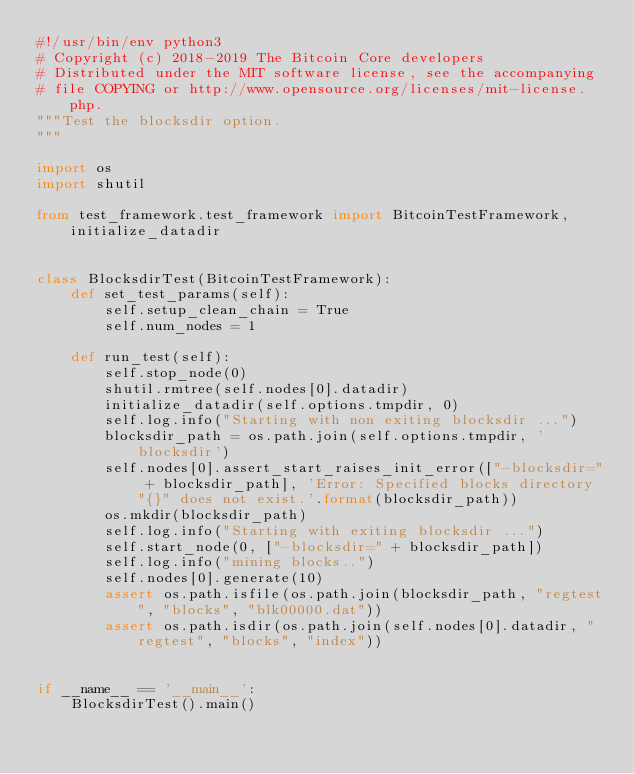<code> <loc_0><loc_0><loc_500><loc_500><_Python_>#!/usr/bin/env python3
# Copyright (c) 2018-2019 The Bitcoin Core developers
# Distributed under the MIT software license, see the accompanying
# file COPYING or http://www.opensource.org/licenses/mit-license.php.
"""Test the blocksdir option.
"""

import os
import shutil

from test_framework.test_framework import BitcoinTestFramework, initialize_datadir


class BlocksdirTest(BitcoinTestFramework):
    def set_test_params(self):
        self.setup_clean_chain = True
        self.num_nodes = 1

    def run_test(self):
        self.stop_node(0)
        shutil.rmtree(self.nodes[0].datadir)
        initialize_datadir(self.options.tmpdir, 0)
        self.log.info("Starting with non exiting blocksdir ...")
        blocksdir_path = os.path.join(self.options.tmpdir, 'blocksdir')
        self.nodes[0].assert_start_raises_init_error(["-blocksdir=" + blocksdir_path], 'Error: Specified blocks directory "{}" does not exist.'.format(blocksdir_path))
        os.mkdir(blocksdir_path)
        self.log.info("Starting with exiting blocksdir ...")
        self.start_node(0, ["-blocksdir=" + blocksdir_path])
        self.log.info("mining blocks..")
        self.nodes[0].generate(10)
        assert os.path.isfile(os.path.join(blocksdir_path, "regtest", "blocks", "blk00000.dat"))
        assert os.path.isdir(os.path.join(self.nodes[0].datadir, "regtest", "blocks", "index"))


if __name__ == '__main__':
    BlocksdirTest().main()
</code> 